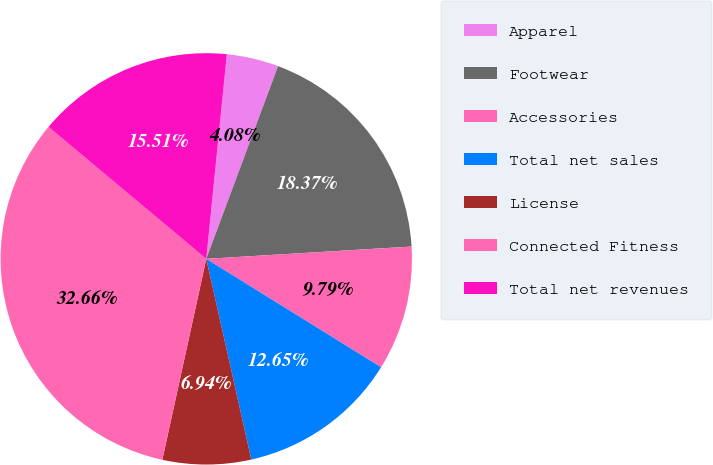Convert chart to OTSL. <chart><loc_0><loc_0><loc_500><loc_500><pie_chart><fcel>Apparel<fcel>Footwear<fcel>Accessories<fcel>Total net sales<fcel>License<fcel>Connected Fitness<fcel>Total net revenues<nl><fcel>4.08%<fcel>18.37%<fcel>9.79%<fcel>12.65%<fcel>6.94%<fcel>32.66%<fcel>15.51%<nl></chart> 